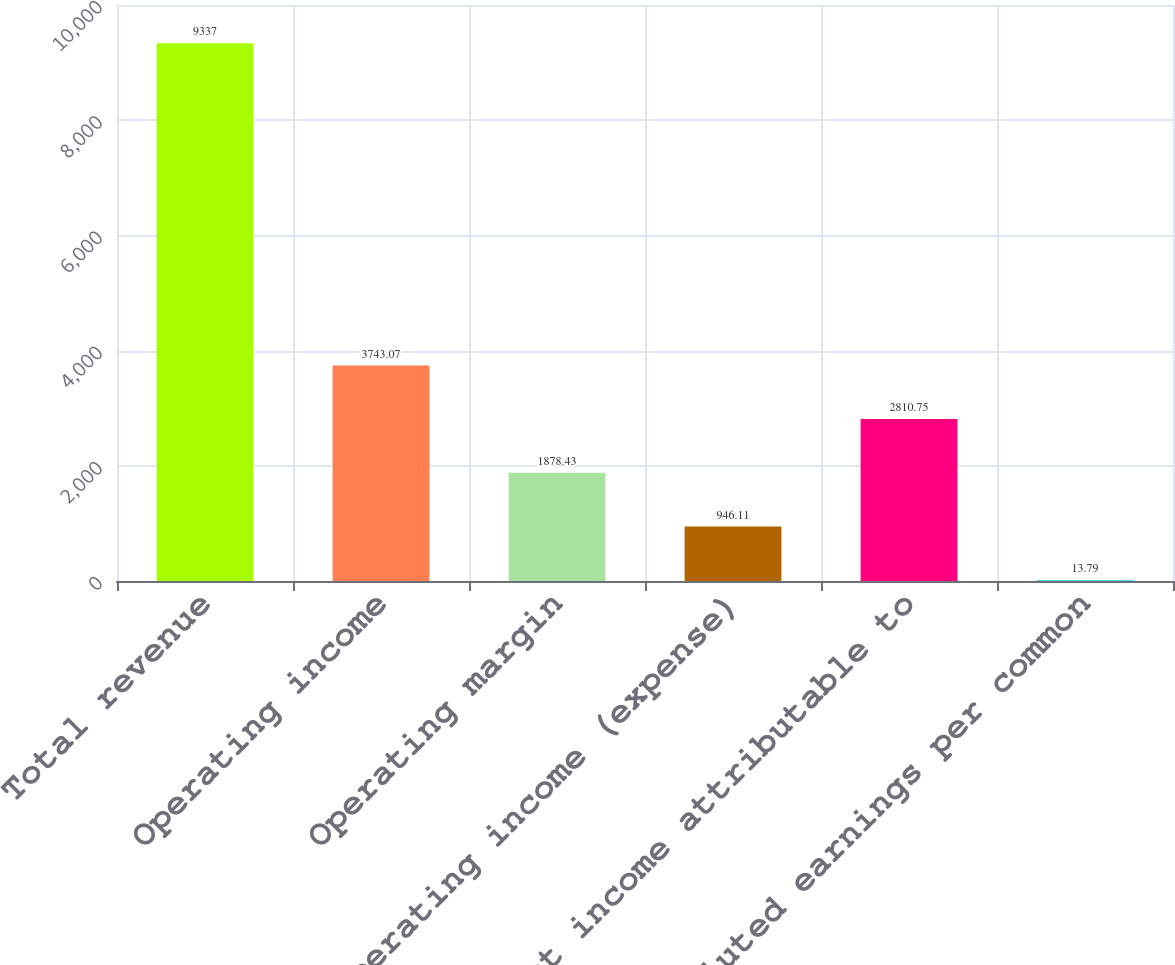Convert chart to OTSL. <chart><loc_0><loc_0><loc_500><loc_500><bar_chart><fcel>Total revenue<fcel>Operating income<fcel>Operating margin<fcel>Nonoperating income (expense)<fcel>Net income attributable to<fcel>Diluted earnings per common<nl><fcel>9337<fcel>3743.07<fcel>1878.43<fcel>946.11<fcel>2810.75<fcel>13.79<nl></chart> 